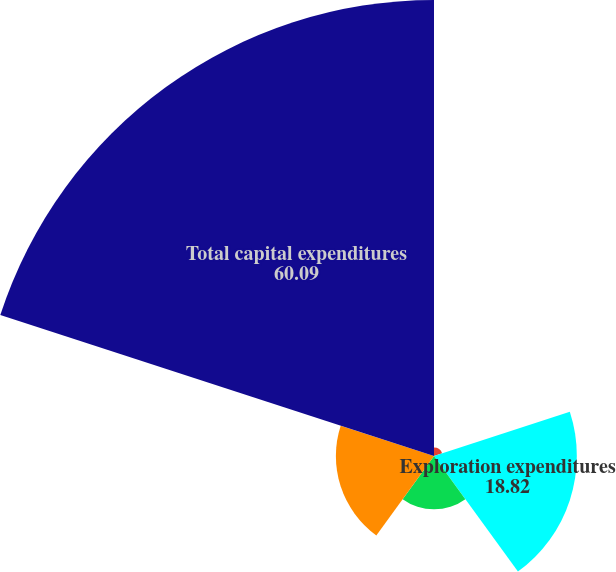Convert chart to OTSL. <chart><loc_0><loc_0><loc_500><loc_500><pie_chart><fcel>Lease acquisition of unproved<fcel>Exploration expenditures<fcel>Corporate and other<fcel>Investments in equity method<fcel>Total capital expenditures<nl><fcel>1.13%<fcel>18.82%<fcel>7.03%<fcel>12.93%<fcel>60.09%<nl></chart> 